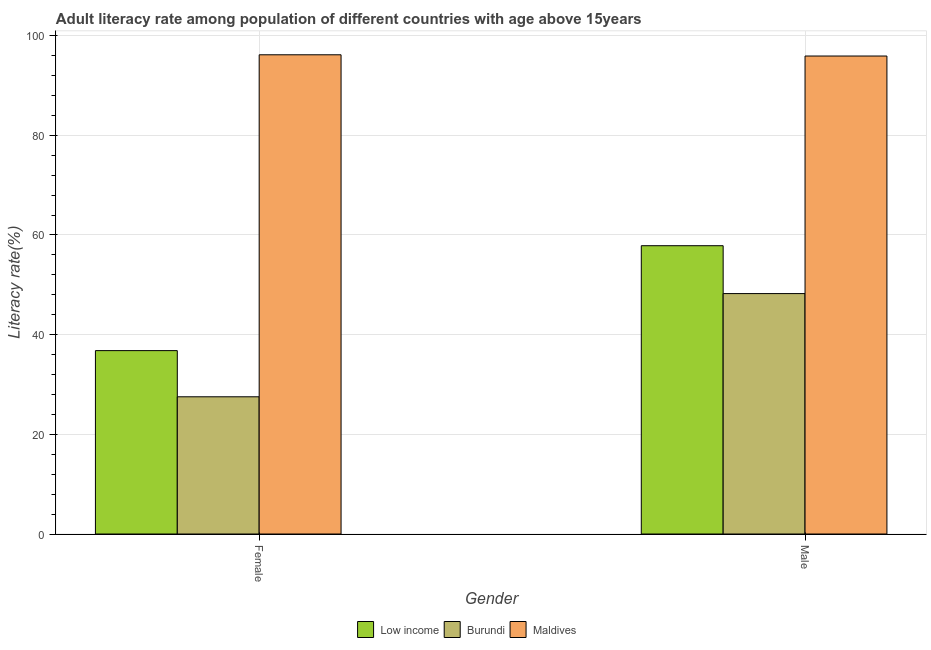Are the number of bars per tick equal to the number of legend labels?
Provide a short and direct response. Yes. How many bars are there on the 1st tick from the left?
Provide a succinct answer. 3. What is the male adult literacy rate in Low income?
Provide a succinct answer. 57.84. Across all countries, what is the maximum male adult literacy rate?
Keep it short and to the point. 95.9. Across all countries, what is the minimum male adult literacy rate?
Provide a succinct answer. 48.24. In which country was the male adult literacy rate maximum?
Your answer should be very brief. Maldives. In which country was the female adult literacy rate minimum?
Keep it short and to the point. Burundi. What is the total male adult literacy rate in the graph?
Provide a succinct answer. 201.98. What is the difference between the male adult literacy rate in Burundi and that in Maldives?
Offer a very short reply. -47.66. What is the difference between the male adult literacy rate in Burundi and the female adult literacy rate in Maldives?
Give a very brief answer. -47.91. What is the average female adult literacy rate per country?
Provide a short and direct response. 53.49. What is the difference between the male adult literacy rate and female adult literacy rate in Maldives?
Your answer should be very brief. -0.25. In how many countries, is the male adult literacy rate greater than 84 %?
Offer a terse response. 1. What is the ratio of the male adult literacy rate in Maldives to that in Burundi?
Provide a succinct answer. 1.99. What does the 2nd bar from the left in Female represents?
Make the answer very short. Burundi. What does the 1st bar from the right in Male represents?
Keep it short and to the point. Maldives. Are all the bars in the graph horizontal?
Provide a short and direct response. No. How many countries are there in the graph?
Your response must be concise. 3. Does the graph contain any zero values?
Ensure brevity in your answer.  No. Does the graph contain grids?
Your answer should be compact. Yes. How many legend labels are there?
Your response must be concise. 3. How are the legend labels stacked?
Your answer should be compact. Horizontal. What is the title of the graph?
Provide a short and direct response. Adult literacy rate among population of different countries with age above 15years. Does "Greece" appear as one of the legend labels in the graph?
Offer a very short reply. No. What is the label or title of the Y-axis?
Provide a short and direct response. Literacy rate(%). What is the Literacy rate(%) in Low income in Female?
Give a very brief answer. 36.79. What is the Literacy rate(%) of Burundi in Female?
Give a very brief answer. 27.53. What is the Literacy rate(%) in Maldives in Female?
Provide a short and direct response. 96.15. What is the Literacy rate(%) in Low income in Male?
Provide a short and direct response. 57.84. What is the Literacy rate(%) of Burundi in Male?
Provide a succinct answer. 48.24. What is the Literacy rate(%) in Maldives in Male?
Provide a succinct answer. 95.9. Across all Gender, what is the maximum Literacy rate(%) of Low income?
Keep it short and to the point. 57.84. Across all Gender, what is the maximum Literacy rate(%) in Burundi?
Offer a very short reply. 48.24. Across all Gender, what is the maximum Literacy rate(%) of Maldives?
Provide a short and direct response. 96.15. Across all Gender, what is the minimum Literacy rate(%) in Low income?
Keep it short and to the point. 36.79. Across all Gender, what is the minimum Literacy rate(%) in Burundi?
Keep it short and to the point. 27.53. Across all Gender, what is the minimum Literacy rate(%) in Maldives?
Provide a short and direct response. 95.9. What is the total Literacy rate(%) in Low income in the graph?
Make the answer very short. 94.63. What is the total Literacy rate(%) in Burundi in the graph?
Provide a succinct answer. 75.77. What is the total Literacy rate(%) of Maldives in the graph?
Offer a terse response. 192.04. What is the difference between the Literacy rate(%) of Low income in Female and that in Male?
Give a very brief answer. -21.05. What is the difference between the Literacy rate(%) in Burundi in Female and that in Male?
Ensure brevity in your answer.  -20.71. What is the difference between the Literacy rate(%) in Maldives in Female and that in Male?
Offer a very short reply. 0.25. What is the difference between the Literacy rate(%) of Low income in Female and the Literacy rate(%) of Burundi in Male?
Offer a terse response. -11.44. What is the difference between the Literacy rate(%) in Low income in Female and the Literacy rate(%) in Maldives in Male?
Offer a terse response. -59.1. What is the difference between the Literacy rate(%) in Burundi in Female and the Literacy rate(%) in Maldives in Male?
Your answer should be very brief. -68.37. What is the average Literacy rate(%) in Low income per Gender?
Your answer should be compact. 47.32. What is the average Literacy rate(%) of Burundi per Gender?
Keep it short and to the point. 37.88. What is the average Literacy rate(%) in Maldives per Gender?
Give a very brief answer. 96.02. What is the difference between the Literacy rate(%) of Low income and Literacy rate(%) of Burundi in Female?
Provide a short and direct response. 9.26. What is the difference between the Literacy rate(%) of Low income and Literacy rate(%) of Maldives in Female?
Give a very brief answer. -59.35. What is the difference between the Literacy rate(%) of Burundi and Literacy rate(%) of Maldives in Female?
Provide a short and direct response. -68.62. What is the difference between the Literacy rate(%) of Low income and Literacy rate(%) of Burundi in Male?
Your response must be concise. 9.61. What is the difference between the Literacy rate(%) of Low income and Literacy rate(%) of Maldives in Male?
Your answer should be compact. -38.06. What is the difference between the Literacy rate(%) of Burundi and Literacy rate(%) of Maldives in Male?
Provide a succinct answer. -47.66. What is the ratio of the Literacy rate(%) of Low income in Female to that in Male?
Provide a succinct answer. 0.64. What is the ratio of the Literacy rate(%) of Burundi in Female to that in Male?
Your response must be concise. 0.57. What is the difference between the highest and the second highest Literacy rate(%) in Low income?
Your response must be concise. 21.05. What is the difference between the highest and the second highest Literacy rate(%) of Burundi?
Keep it short and to the point. 20.71. What is the difference between the highest and the second highest Literacy rate(%) in Maldives?
Give a very brief answer. 0.25. What is the difference between the highest and the lowest Literacy rate(%) in Low income?
Your response must be concise. 21.05. What is the difference between the highest and the lowest Literacy rate(%) in Burundi?
Ensure brevity in your answer.  20.71. What is the difference between the highest and the lowest Literacy rate(%) of Maldives?
Provide a succinct answer. 0.25. 